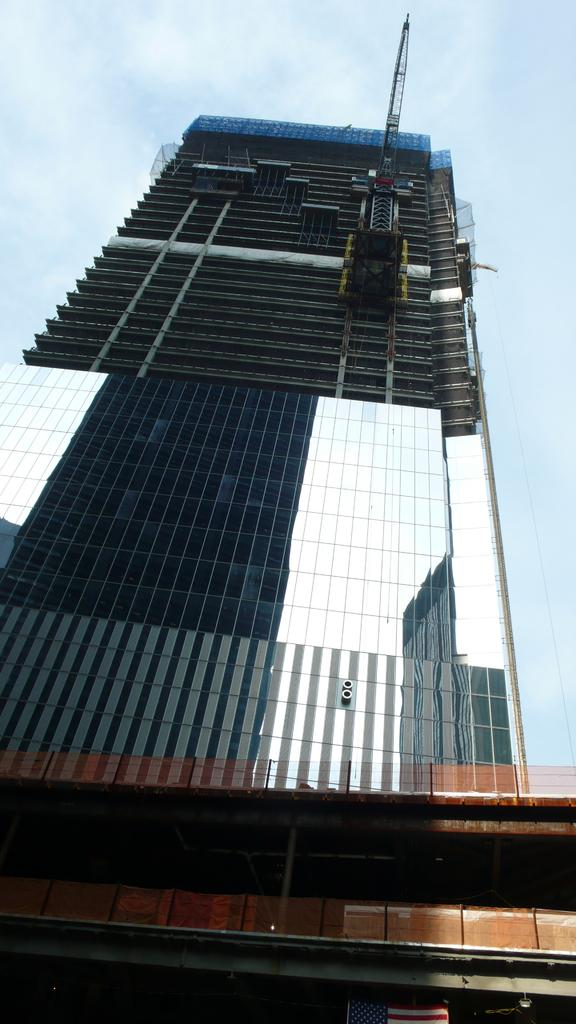What type of structure is visible in the image? There is a building in the image. What feature can be observed on the building? The building has glass windows. What can be seen in the sky in the background of the image? There are clouds in the sky in the background of the image. How does the building slip on the ice in the image? There is no ice present in the image, and the building does not slip. 